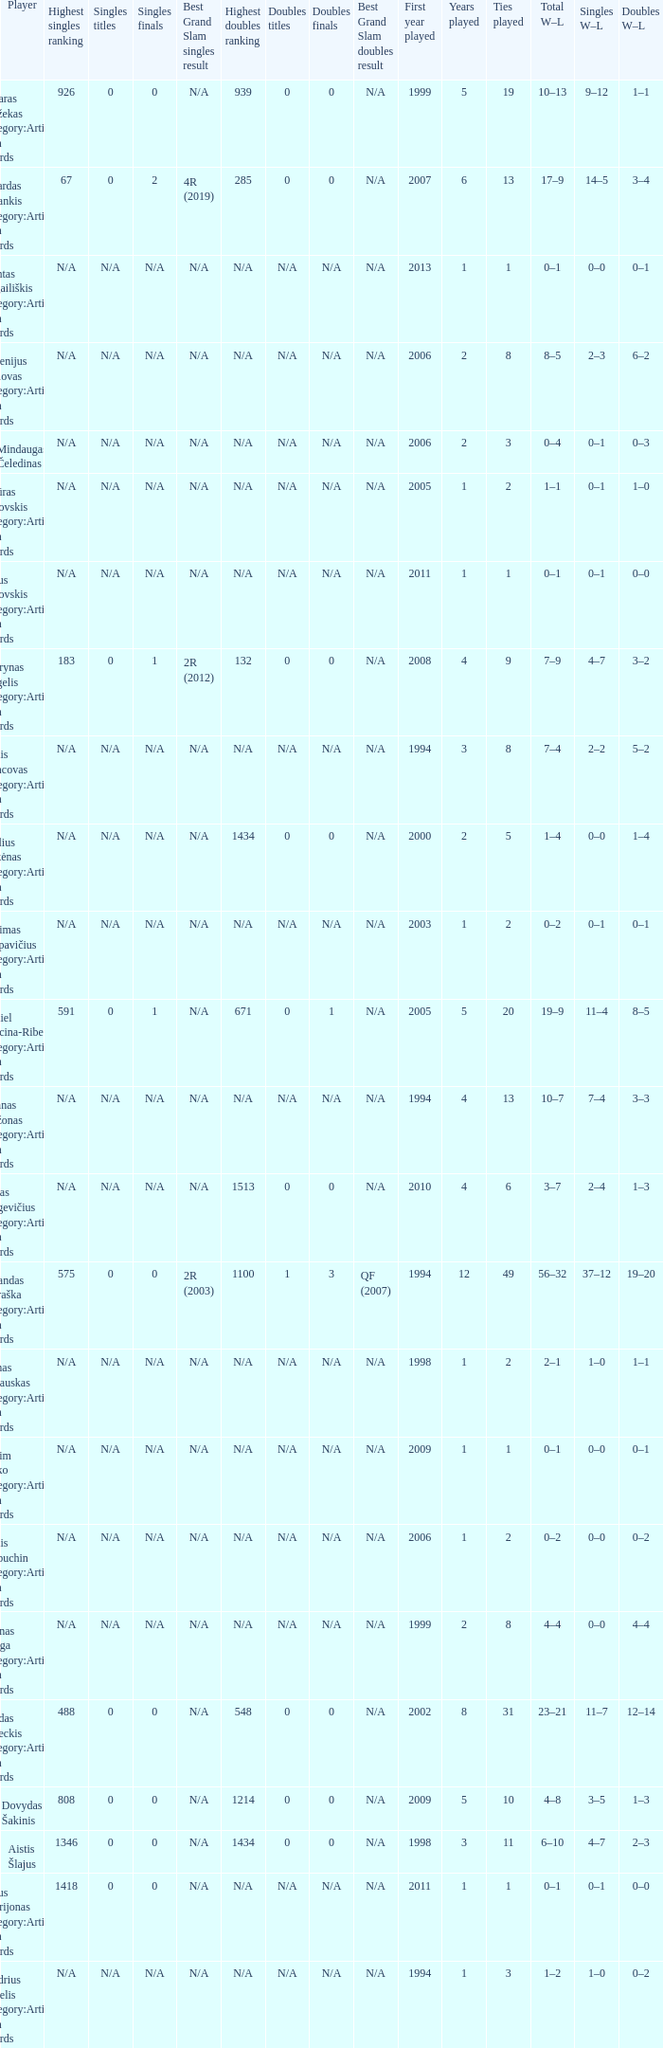Name the minimum tiesplayed for 6 years 13.0. 